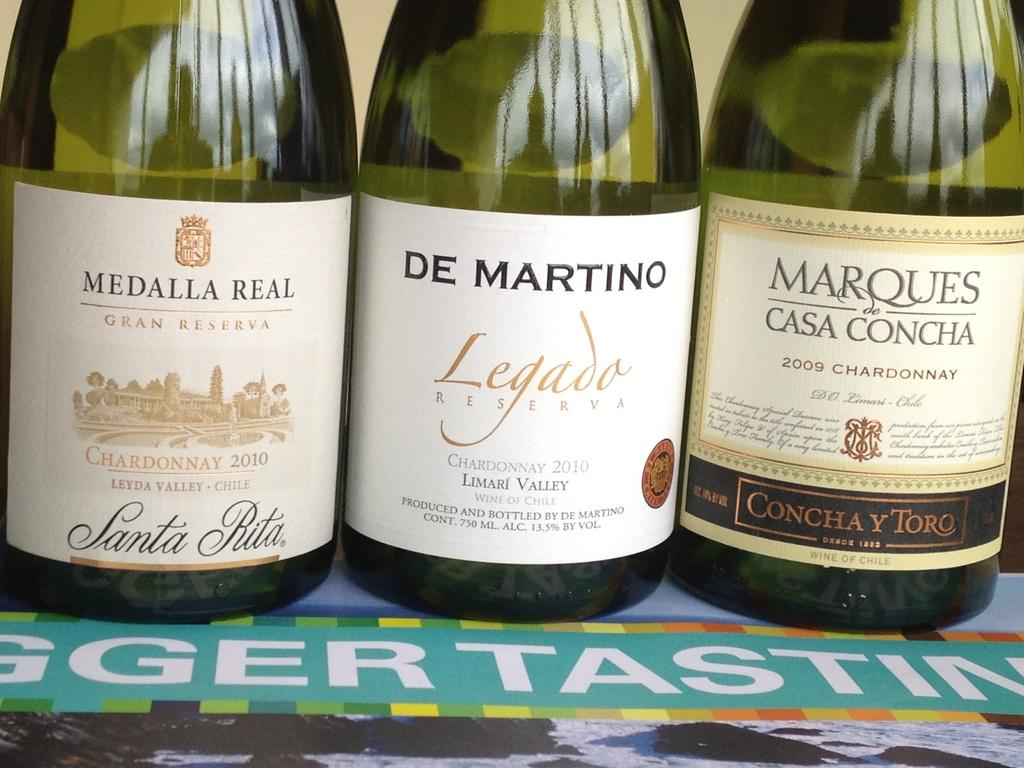<image>
Provide a brief description of the given image. "DE MARTINO" is on one of three bottles. 